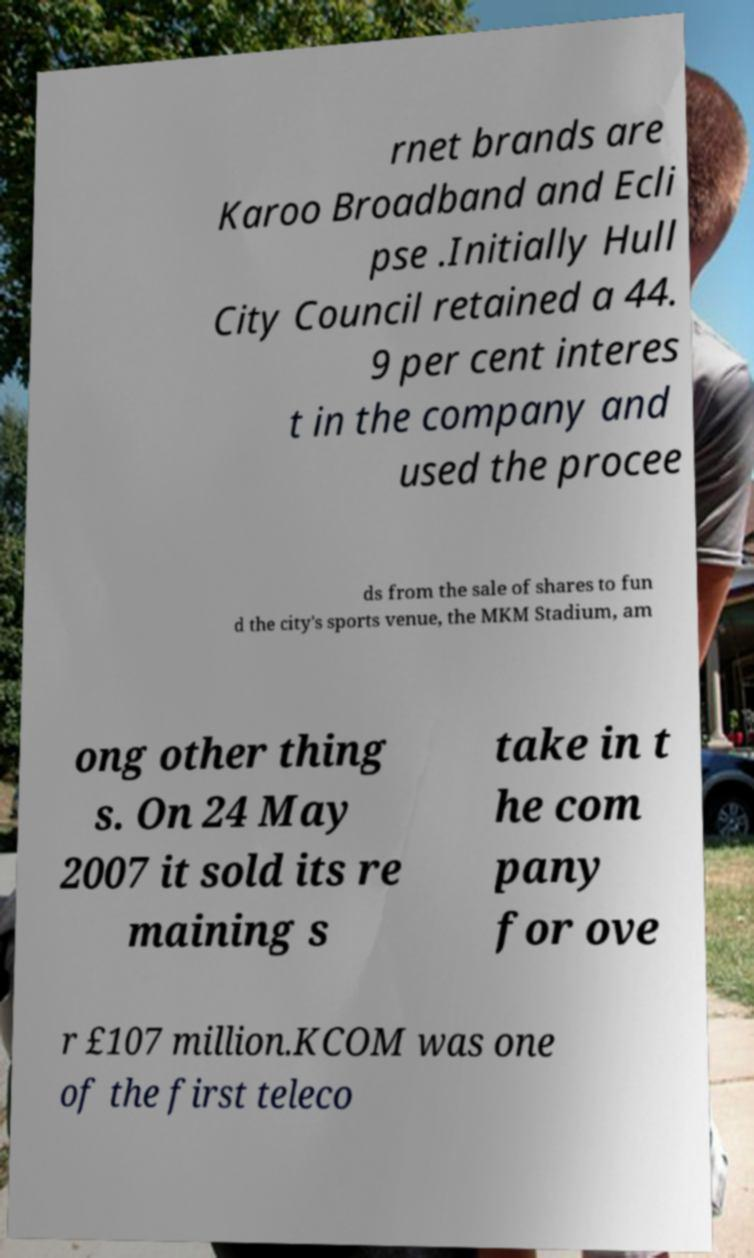Could you extract and type out the text from this image? rnet brands are Karoo Broadband and Ecli pse .Initially Hull City Council retained a 44. 9 per cent interes t in the company and used the procee ds from the sale of shares to fun d the city's sports venue, the MKM Stadium, am ong other thing s. On 24 May 2007 it sold its re maining s take in t he com pany for ove r £107 million.KCOM was one of the first teleco 